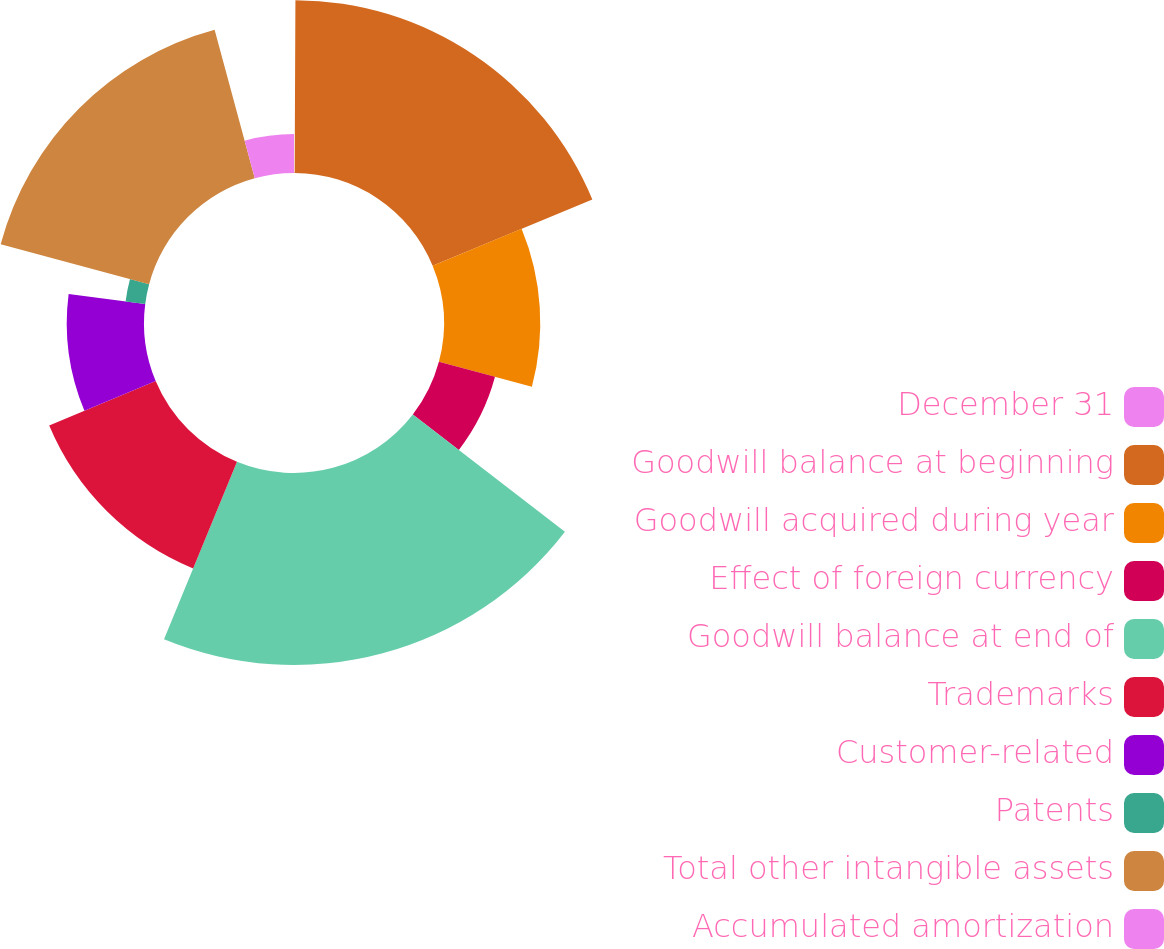Convert chart. <chart><loc_0><loc_0><loc_500><loc_500><pie_chart><fcel>December 31<fcel>Goodwill balance at beginning<fcel>Goodwill acquired during year<fcel>Effect of foreign currency<fcel>Goodwill balance at end of<fcel>Trademarks<fcel>Customer-related<fcel>Patents<fcel>Total other intangible assets<fcel>Accumulated amortization<nl><fcel>0.07%<fcel>18.69%<fcel>10.41%<fcel>6.28%<fcel>20.76%<fcel>12.48%<fcel>8.35%<fcel>2.14%<fcel>16.62%<fcel>4.21%<nl></chart> 